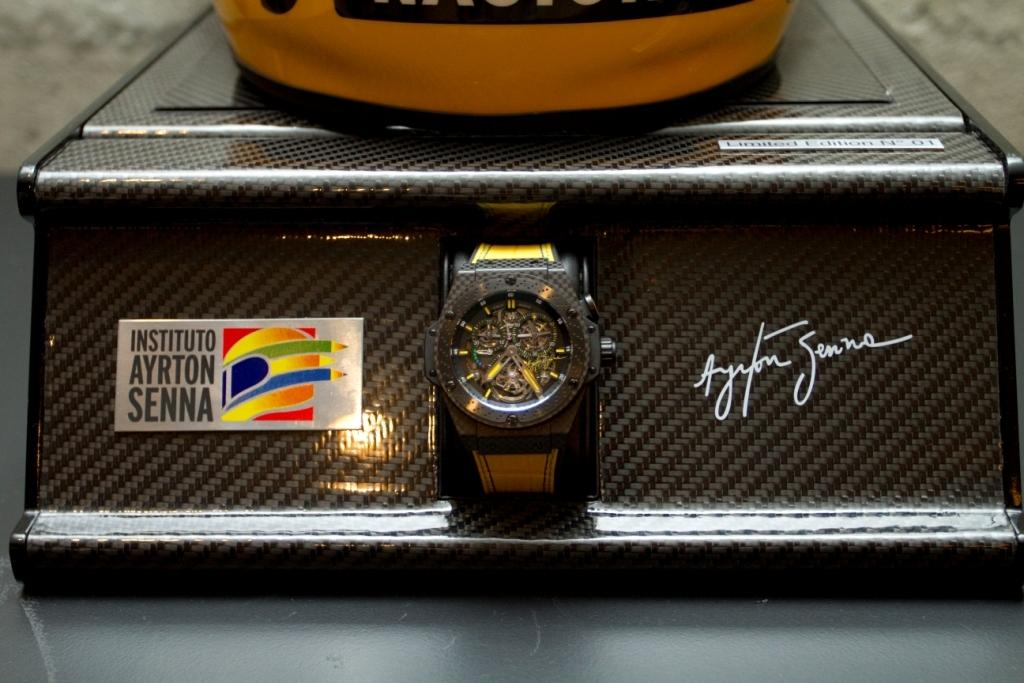<image>
Summarize the visual content of the image. Nice black watch from Instituto Ayrton Senna on the left side 